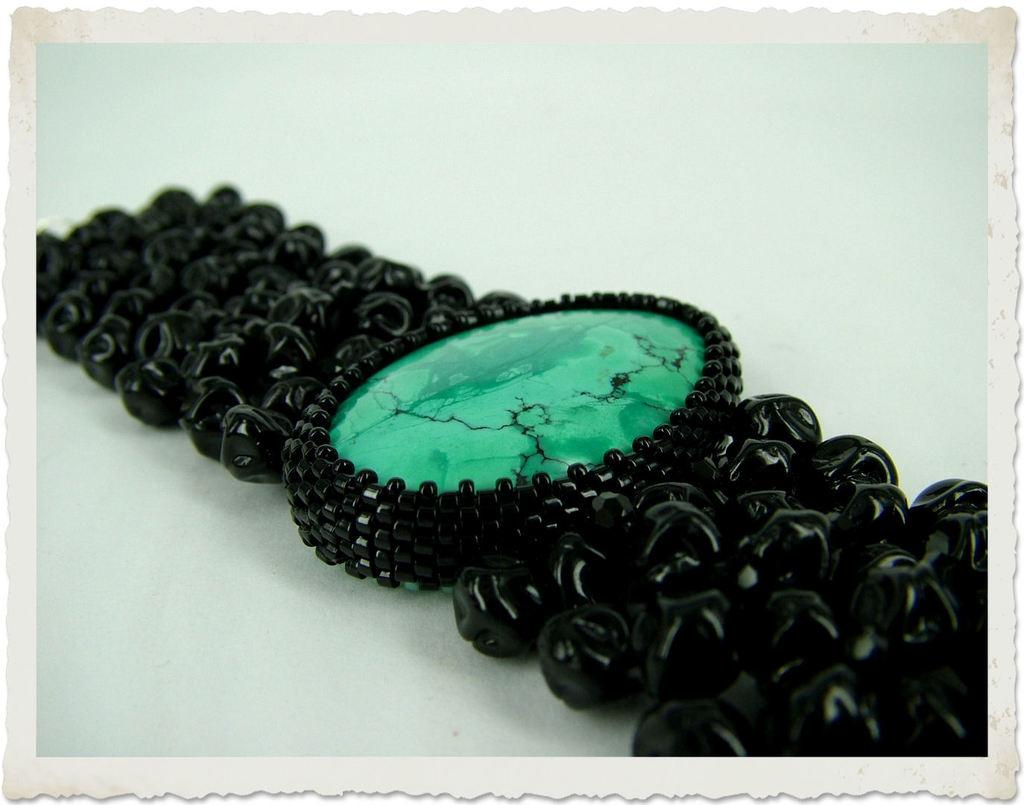What is the main subject of the image? The main subject of the image is a photograph. Can you describe the photograph in more detail? The photograph features a black color band with a green color glass in the middle of the band. How does the bean help the mom during the flight in the image? There is no bean, mom, or flight present in the image; it only features a photograph with a black color band and a green color glass in the middle of the band. 